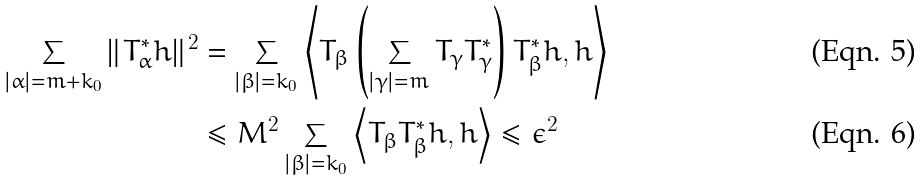<formula> <loc_0><loc_0><loc_500><loc_500>\sum _ { | \alpha | = m + k _ { 0 } } \| T _ { \alpha } ^ { * } h \| ^ { 2 } & = \sum _ { | \beta | = k _ { 0 } } \left < T _ { \beta } \left ( \sum _ { | \gamma | = m } T _ { \gamma } T _ { \gamma } ^ { * } \right ) T _ { \beta } ^ { * } h , h \right > \\ & \leq M ^ { 2 } \sum _ { | \beta | = k _ { 0 } } \left < T _ { \beta } T _ { \beta } ^ { * } h , h \right > \leq \epsilon ^ { 2 }</formula> 